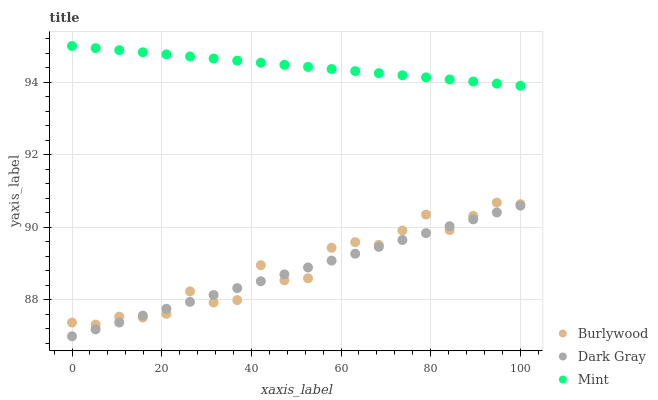Does Dark Gray have the minimum area under the curve?
Answer yes or no. Yes. Does Mint have the maximum area under the curve?
Answer yes or no. Yes. Does Mint have the minimum area under the curve?
Answer yes or no. No. Does Dark Gray have the maximum area under the curve?
Answer yes or no. No. Is Dark Gray the smoothest?
Answer yes or no. Yes. Is Burlywood the roughest?
Answer yes or no. Yes. Is Mint the smoothest?
Answer yes or no. No. Is Mint the roughest?
Answer yes or no. No. Does Dark Gray have the lowest value?
Answer yes or no. Yes. Does Mint have the lowest value?
Answer yes or no. No. Does Mint have the highest value?
Answer yes or no. Yes. Does Dark Gray have the highest value?
Answer yes or no. No. Is Dark Gray less than Mint?
Answer yes or no. Yes. Is Mint greater than Burlywood?
Answer yes or no. Yes. Does Dark Gray intersect Burlywood?
Answer yes or no. Yes. Is Dark Gray less than Burlywood?
Answer yes or no. No. Is Dark Gray greater than Burlywood?
Answer yes or no. No. Does Dark Gray intersect Mint?
Answer yes or no. No. 